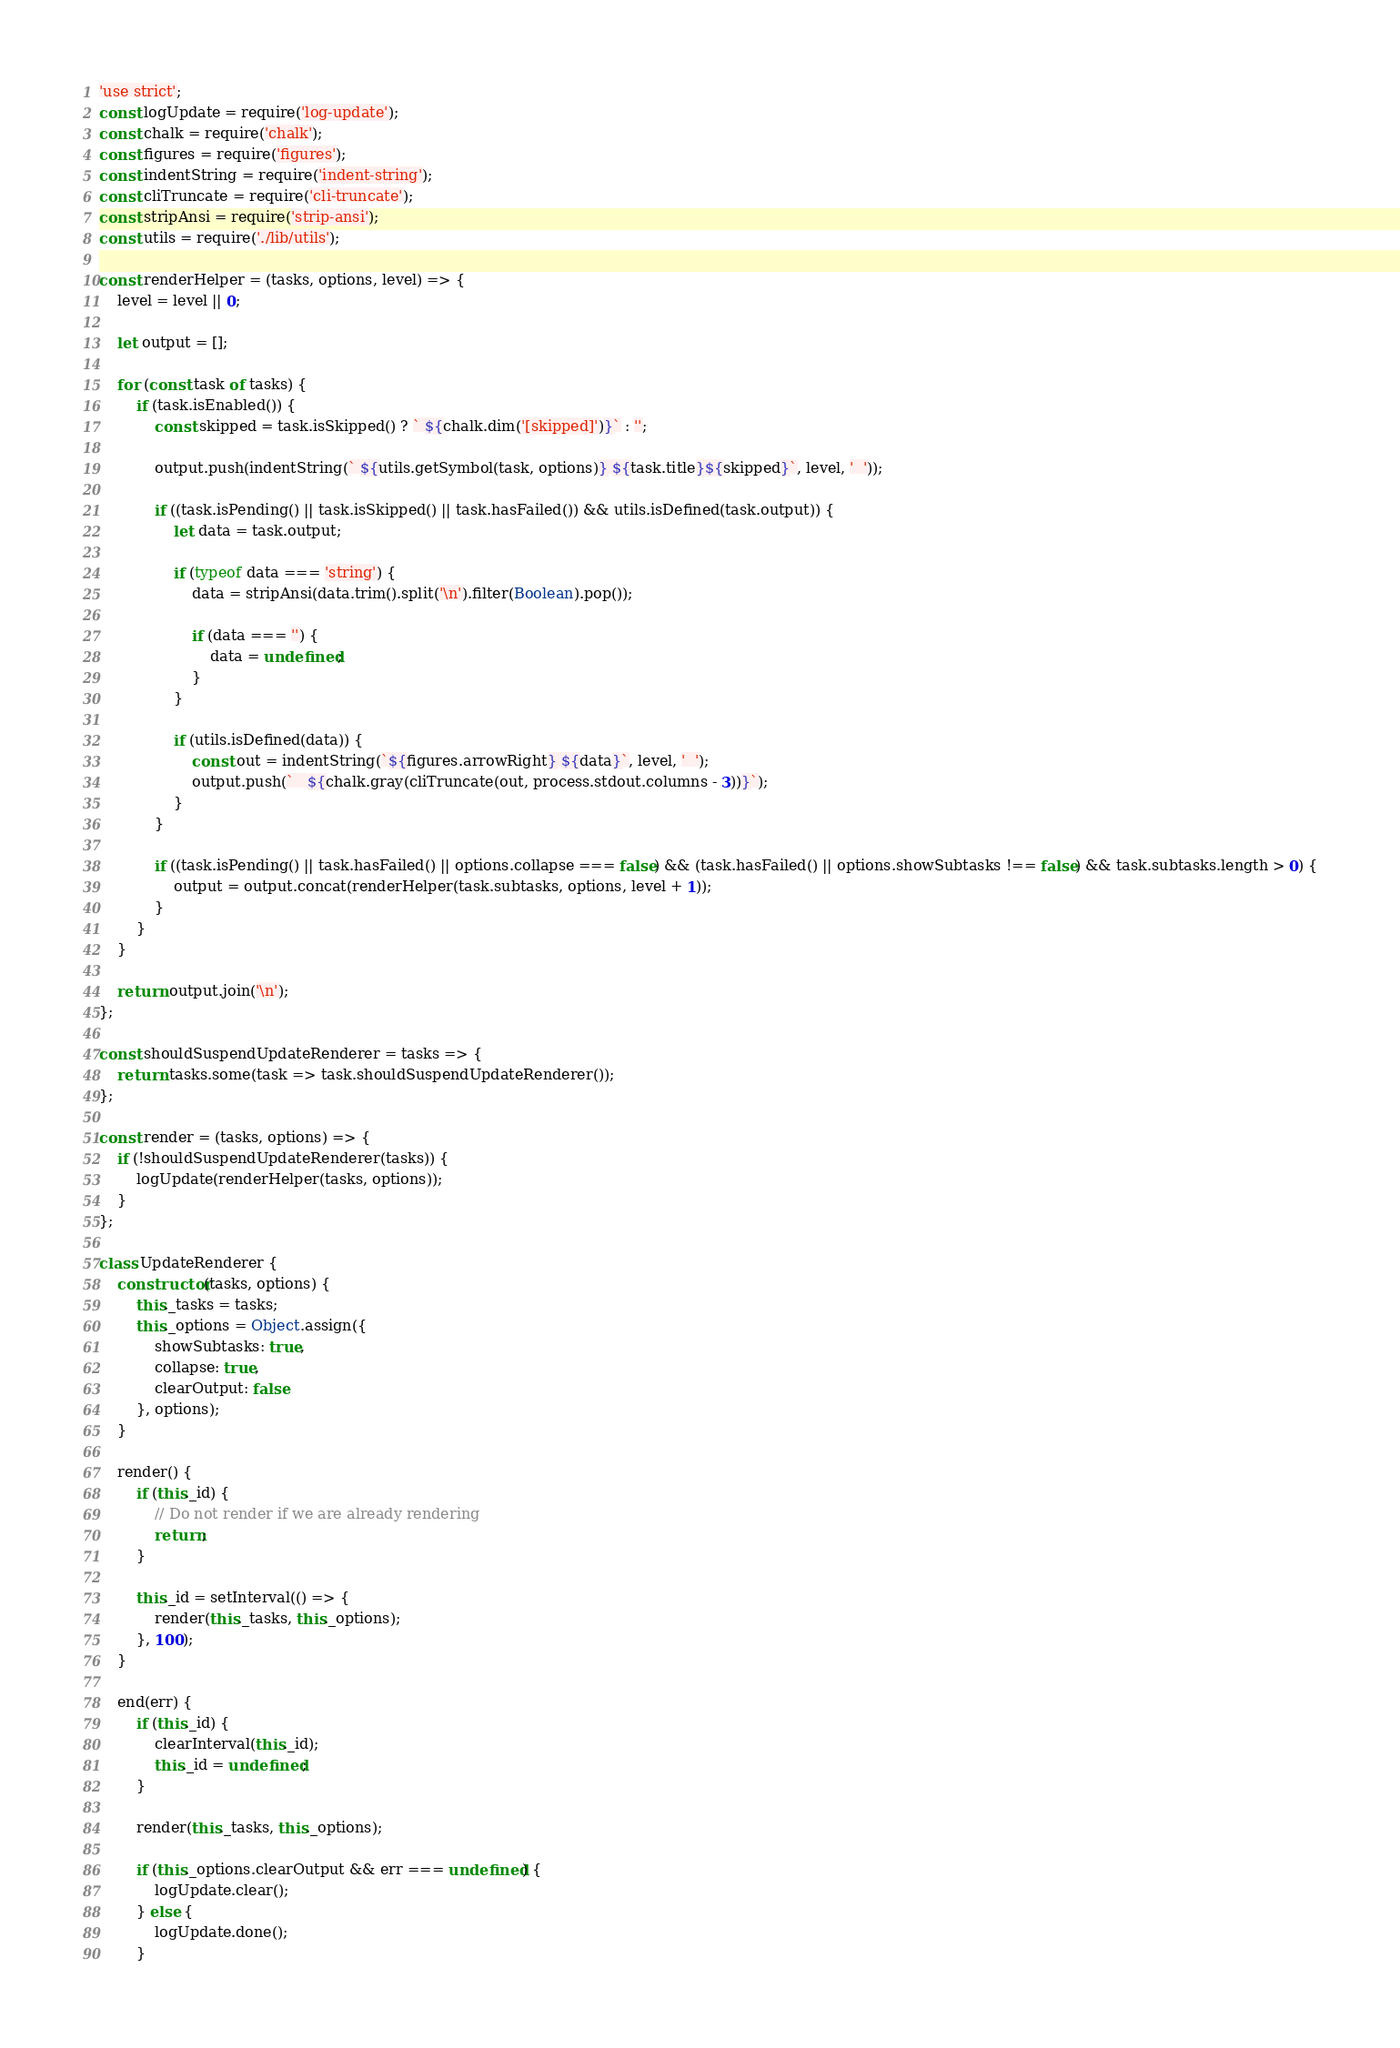<code> <loc_0><loc_0><loc_500><loc_500><_JavaScript_>'use strict';
const logUpdate = require('log-update');
const chalk = require('chalk');
const figures = require('figures');
const indentString = require('indent-string');
const cliTruncate = require('cli-truncate');
const stripAnsi = require('strip-ansi');
const utils = require('./lib/utils');

const renderHelper = (tasks, options, level) => {
	level = level || 0;

	let output = [];

	for (const task of tasks) {
		if (task.isEnabled()) {
			const skipped = task.isSkipped() ? ` ${chalk.dim('[skipped]')}` : '';

			output.push(indentString(` ${utils.getSymbol(task, options)} ${task.title}${skipped}`, level, '  '));

			if ((task.isPending() || task.isSkipped() || task.hasFailed()) && utils.isDefined(task.output)) {
				let data = task.output;

				if (typeof data === 'string') {
					data = stripAnsi(data.trim().split('\n').filter(Boolean).pop());

					if (data === '') {
						data = undefined;
					}
				}

				if (utils.isDefined(data)) {
					const out = indentString(`${figures.arrowRight} ${data}`, level, '  ');
					output.push(`   ${chalk.gray(cliTruncate(out, process.stdout.columns - 3))}`);
				}
			}

			if ((task.isPending() || task.hasFailed() || options.collapse === false) && (task.hasFailed() || options.showSubtasks !== false) && task.subtasks.length > 0) {
				output = output.concat(renderHelper(task.subtasks, options, level + 1));
			}
		}
	}

	return output.join('\n');
};

const shouldSuspendUpdateRenderer = tasks => {
	return tasks.some(task => task.shouldSuspendUpdateRenderer());
};

const render = (tasks, options) => {
	if (!shouldSuspendUpdateRenderer(tasks)) {
		logUpdate(renderHelper(tasks, options));
	}
};

class UpdateRenderer {
	constructor(tasks, options) {
		this._tasks = tasks;
		this._options = Object.assign({
			showSubtasks: true,
			collapse: true,
			clearOutput: false
		}, options);
	}

	render() {
		if (this._id) {
			// Do not render if we are already rendering
			return;
		}

		this._id = setInterval(() => {
			render(this._tasks, this._options);
		}, 100);
	}

	end(err) {
		if (this._id) {
			clearInterval(this._id);
			this._id = undefined;
		}

		render(this._tasks, this._options);

		if (this._options.clearOutput && err === undefined) {
			logUpdate.clear();
		} else {
			logUpdate.done();
		}</code> 